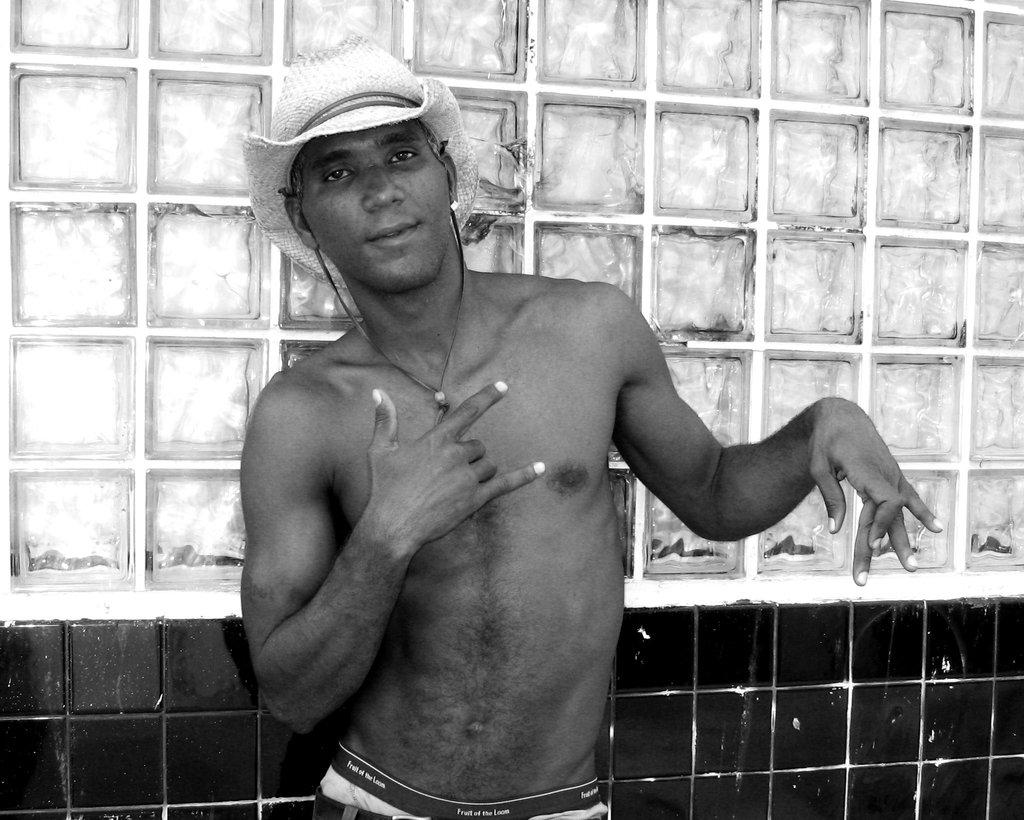What is present in the image? There is a man in the image. Can you describe the man's attire? The man is wearing a hat. What direction is the man looking in the image? The man is looking forward. What is one of the architectural features visible in the image? There is a wall in the image. What type of material is covering the wall? The wall has tiles on it. How does the man plan to increase the number of babies at the station in the image? There is no mention of babies or a station in the image, nor is there any indication of an increase in the number of babies. 